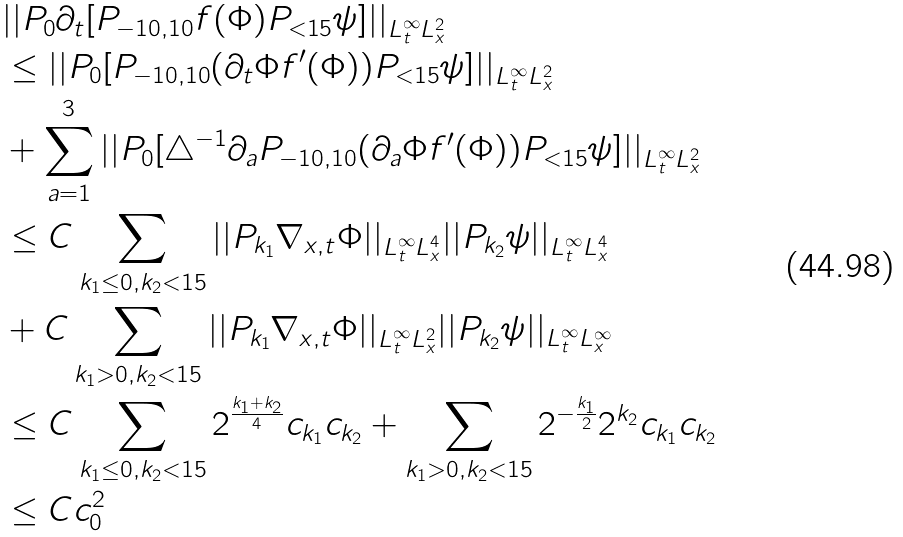<formula> <loc_0><loc_0><loc_500><loc_500>& | | P _ { 0 } \partial _ { t } [ P _ { - 1 0 , 1 0 } f ( \Phi ) P _ { < 1 5 } \psi ] | | _ { L _ { t } ^ { \infty } L _ { x } ^ { 2 } } \\ & \leq | | P _ { 0 } [ P _ { - 1 0 , 1 0 } ( \partial _ { t } \Phi f ^ { \prime } ( \Phi ) ) P _ { < 1 5 } \psi ] | | _ { L _ { t } ^ { \infty } L _ { x } ^ { 2 } } \\ & + \sum _ { a = 1 } ^ { 3 } | | P _ { 0 } [ \triangle ^ { - 1 } \partial _ { a } P _ { - 1 0 , 1 0 } ( \partial _ { a } \Phi f ^ { \prime } ( \Phi ) ) P _ { < 1 5 } \psi ] | | _ { L _ { t } ^ { \infty } L _ { x } ^ { 2 } } \\ & \leq C \sum _ { k _ { 1 } \leq 0 , k _ { 2 } < 1 5 } | | P _ { k _ { 1 } } \nabla _ { x , t } \Phi | | _ { L _ { t } ^ { \infty } L _ { x } ^ { 4 } } | | P _ { k _ { 2 } } \psi | | _ { L _ { t } ^ { \infty } L _ { x } ^ { 4 } } \\ & + C \sum _ { k _ { 1 } > 0 , k _ { 2 } < 1 5 } | | P _ { k _ { 1 } } \nabla _ { x , t } \Phi | | _ { L _ { t } ^ { \infty } L _ { x } ^ { 2 } } | | P _ { k _ { 2 } } \psi | | _ { L _ { t } ^ { \infty } L _ { x } ^ { \infty } } \\ & \leq C \sum _ { k _ { 1 } \leq 0 , k _ { 2 } < 1 5 } 2 ^ { \frac { k _ { 1 } + k _ { 2 } } { 4 } } c _ { k _ { 1 } } c _ { k _ { 2 } } + \sum _ { k _ { 1 } > 0 , k _ { 2 } < 1 5 } 2 ^ { - \frac { k _ { 1 } } { 2 } } 2 ^ { k _ { 2 } } c _ { k _ { 1 } } c _ { k _ { 2 } } \\ & \leq C c _ { 0 } ^ { 2 } \\</formula> 